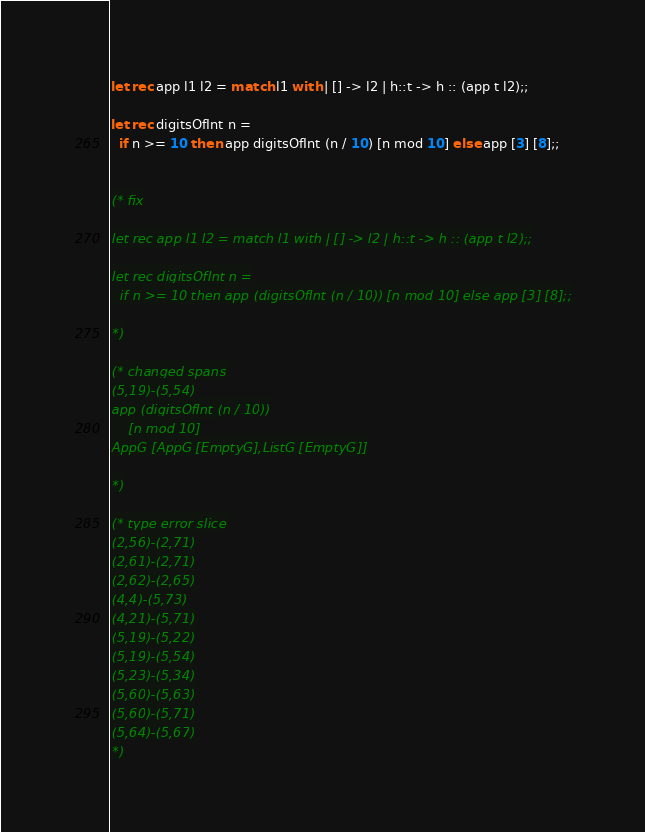Convert code to text. <code><loc_0><loc_0><loc_500><loc_500><_OCaml_>let rec app l1 l2 = match l1 with | [] -> l2 | h::t -> h :: (app t l2);;

let rec digitsOfInt n =
  if n >= 10 then app digitsOfInt (n / 10) [n mod 10] else app [3] [8];;


(* fix

let rec app l1 l2 = match l1 with | [] -> l2 | h::t -> h :: (app t l2);;

let rec digitsOfInt n =
  if n >= 10 then app (digitsOfInt (n / 10)) [n mod 10] else app [3] [8];;

*)

(* changed spans
(5,19)-(5,54)
app (digitsOfInt (n / 10))
    [n mod 10]
AppG [AppG [EmptyG],ListG [EmptyG]]

*)

(* type error slice
(2,56)-(2,71)
(2,61)-(2,71)
(2,62)-(2,65)
(4,4)-(5,73)
(4,21)-(5,71)
(5,19)-(5,22)
(5,19)-(5,54)
(5,23)-(5,34)
(5,60)-(5,63)
(5,60)-(5,71)
(5,64)-(5,67)
*)
</code> 